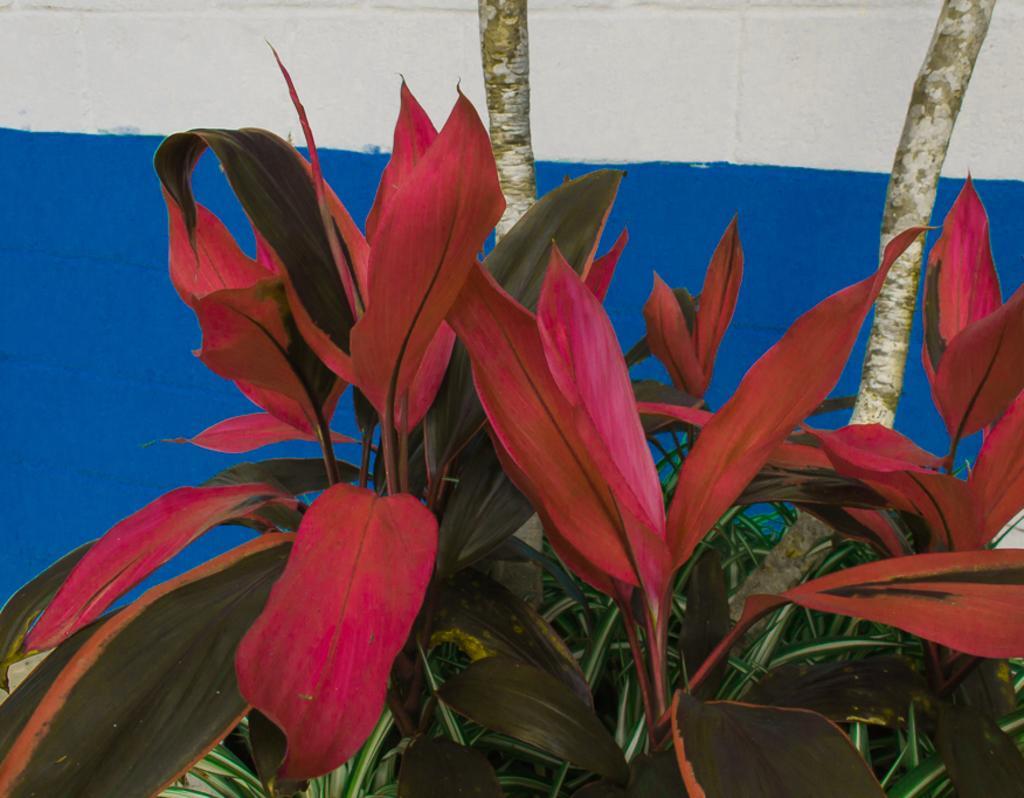Can you describe this image briefly? In this picture I can see planets, there are branches, and in the background there is a wall. 